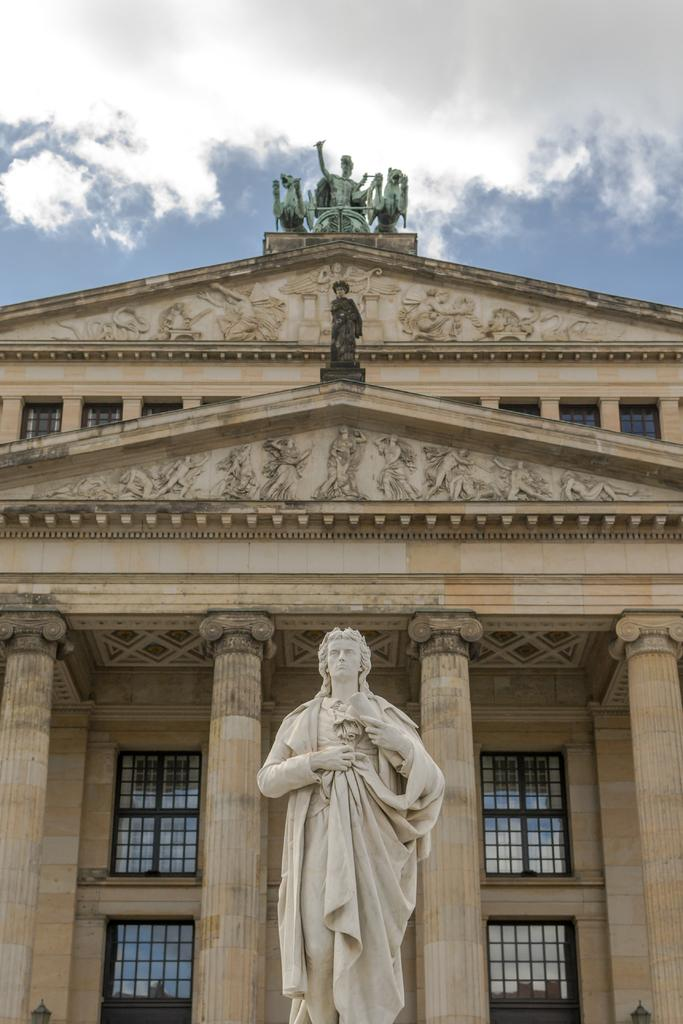What is the main subject in the center of the image? There is a statue in the center of the image. What can be seen in the background of the image? There are buildings and the sky visible in the background of the image. What is the condition of the sky in the image? The sky is visible in the background of the image, and there are clouds present. What type of question is the statue asking in the image? There is no indication in the image that the statue is asking a question. Can you tell me the color of the shoe worn by the statue's brother in the image? There is no shoe or brother mentioned or visible in the image. 